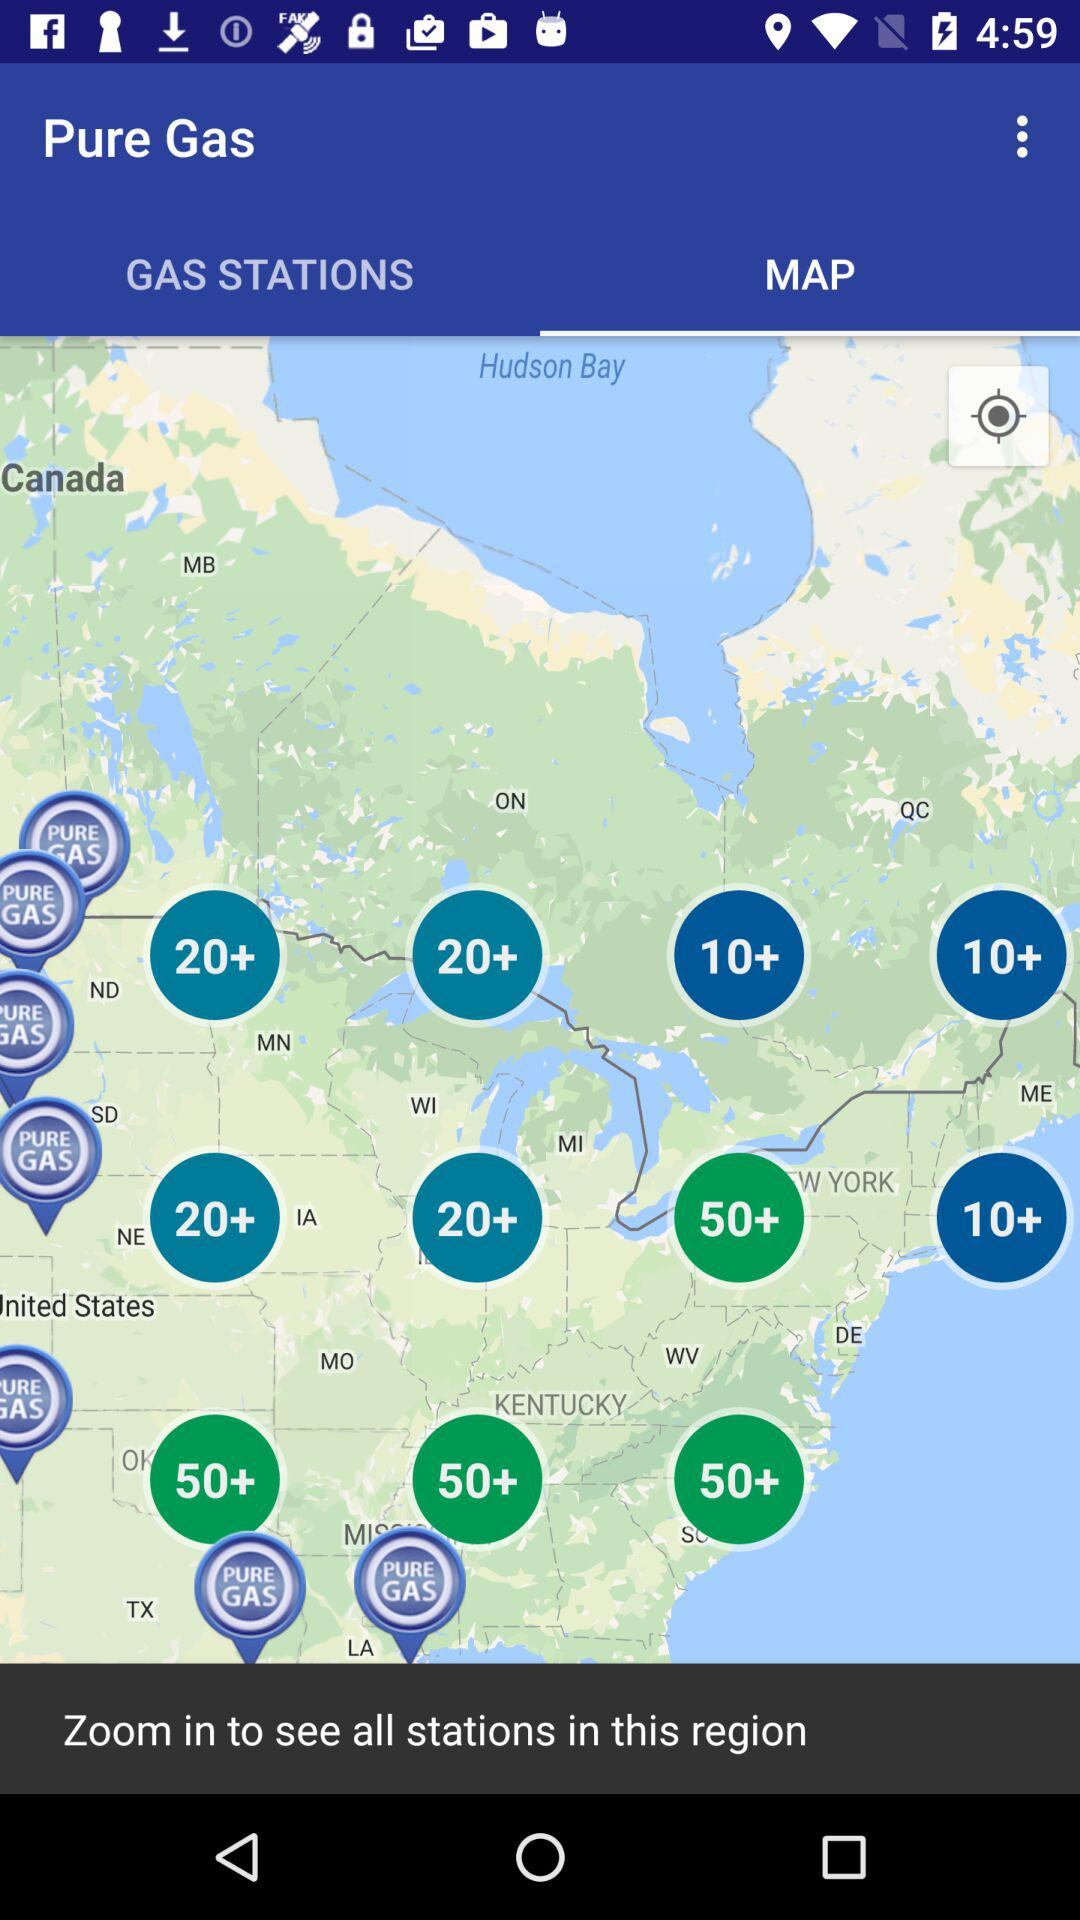Which is the selected tab? The selected tab is "MAP". 